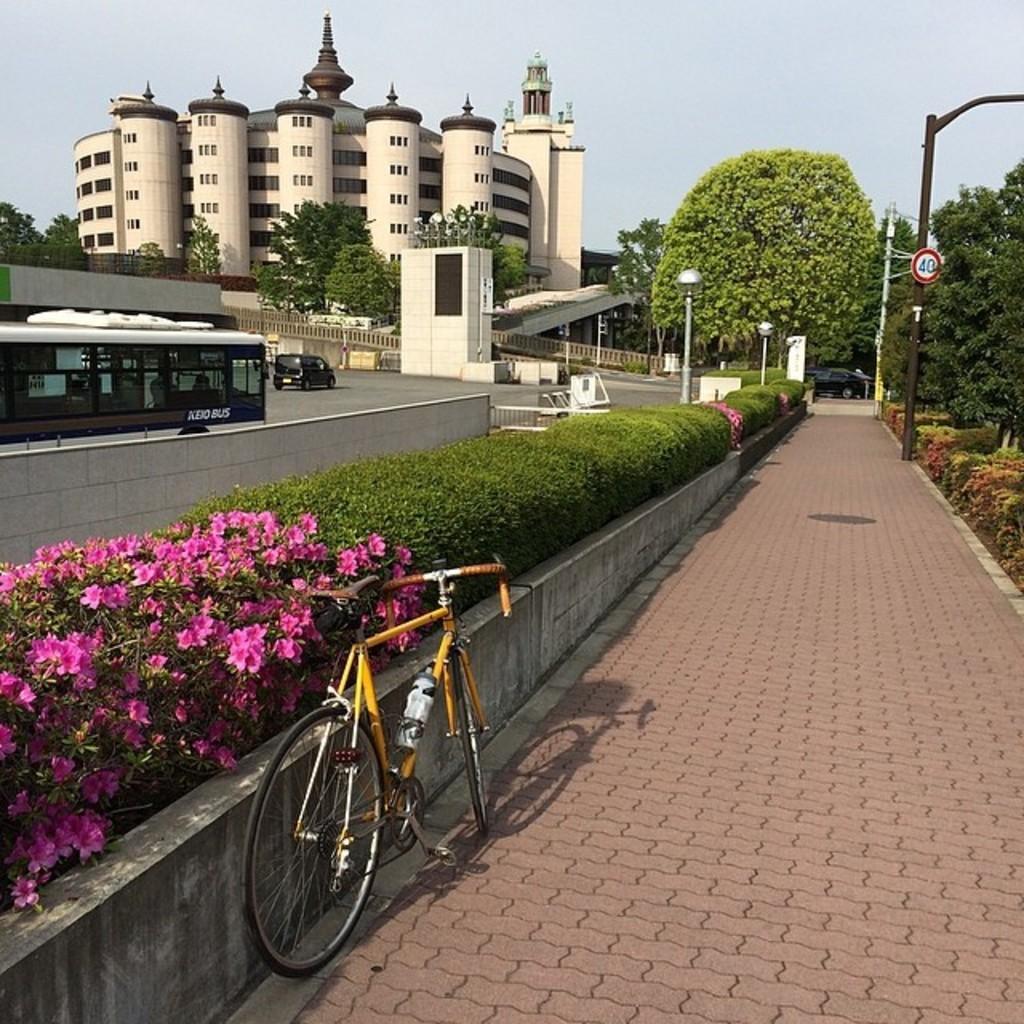Describe this image in one or two sentences. In this image we can see cycle, flowers, plants, trees, street lights, pole, sign board, vehicles, road, buildings and sky. 